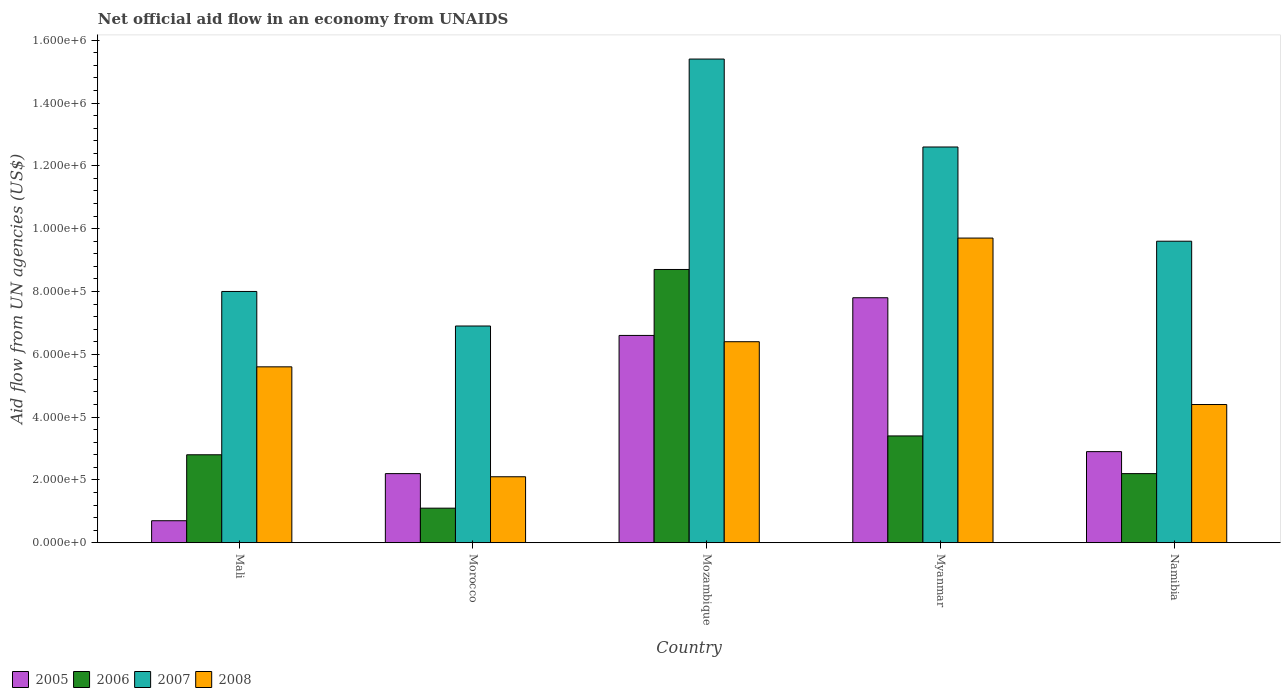How many groups of bars are there?
Provide a short and direct response. 5. Are the number of bars per tick equal to the number of legend labels?
Keep it short and to the point. Yes. What is the label of the 3rd group of bars from the left?
Offer a terse response. Mozambique. What is the net official aid flow in 2008 in Mali?
Provide a succinct answer. 5.60e+05. Across all countries, what is the maximum net official aid flow in 2006?
Offer a very short reply. 8.70e+05. In which country was the net official aid flow in 2008 maximum?
Your answer should be compact. Myanmar. In which country was the net official aid flow in 2005 minimum?
Your answer should be compact. Mali. What is the total net official aid flow in 2007 in the graph?
Give a very brief answer. 5.25e+06. What is the difference between the net official aid flow in 2007 in Mozambique and that in Myanmar?
Offer a terse response. 2.80e+05. What is the difference between the net official aid flow in 2006 in Mali and the net official aid flow in 2005 in Myanmar?
Provide a short and direct response. -5.00e+05. What is the average net official aid flow in 2005 per country?
Your answer should be very brief. 4.04e+05. In how many countries, is the net official aid flow in 2008 greater than 1080000 US$?
Your response must be concise. 0. What is the ratio of the net official aid flow in 2006 in Mali to that in Mozambique?
Keep it short and to the point. 0.32. Is the net official aid flow in 2008 in Mali less than that in Morocco?
Your answer should be very brief. No. Is the difference between the net official aid flow in 2007 in Mozambique and Namibia greater than the difference between the net official aid flow in 2005 in Mozambique and Namibia?
Offer a very short reply. Yes. What is the difference between the highest and the lowest net official aid flow in 2008?
Your answer should be compact. 7.60e+05. In how many countries, is the net official aid flow in 2006 greater than the average net official aid flow in 2006 taken over all countries?
Your answer should be very brief. 1. Is the sum of the net official aid flow in 2006 in Morocco and Namibia greater than the maximum net official aid flow in 2007 across all countries?
Your response must be concise. No. What does the 3rd bar from the left in Morocco represents?
Make the answer very short. 2007. What does the 4th bar from the right in Mozambique represents?
Provide a succinct answer. 2005. How many bars are there?
Your answer should be compact. 20. Are the values on the major ticks of Y-axis written in scientific E-notation?
Offer a terse response. Yes. Does the graph contain grids?
Your response must be concise. No. Where does the legend appear in the graph?
Provide a succinct answer. Bottom left. How many legend labels are there?
Provide a succinct answer. 4. What is the title of the graph?
Offer a terse response. Net official aid flow in an economy from UNAIDS. Does "1980" appear as one of the legend labels in the graph?
Ensure brevity in your answer.  No. What is the label or title of the X-axis?
Provide a succinct answer. Country. What is the label or title of the Y-axis?
Keep it short and to the point. Aid flow from UN agencies (US$). What is the Aid flow from UN agencies (US$) of 2006 in Mali?
Your response must be concise. 2.80e+05. What is the Aid flow from UN agencies (US$) of 2007 in Mali?
Provide a succinct answer. 8.00e+05. What is the Aid flow from UN agencies (US$) of 2008 in Mali?
Your response must be concise. 5.60e+05. What is the Aid flow from UN agencies (US$) in 2005 in Morocco?
Offer a terse response. 2.20e+05. What is the Aid flow from UN agencies (US$) of 2007 in Morocco?
Ensure brevity in your answer.  6.90e+05. What is the Aid flow from UN agencies (US$) in 2005 in Mozambique?
Ensure brevity in your answer.  6.60e+05. What is the Aid flow from UN agencies (US$) of 2006 in Mozambique?
Ensure brevity in your answer.  8.70e+05. What is the Aid flow from UN agencies (US$) in 2007 in Mozambique?
Give a very brief answer. 1.54e+06. What is the Aid flow from UN agencies (US$) in 2008 in Mozambique?
Offer a terse response. 6.40e+05. What is the Aid flow from UN agencies (US$) in 2005 in Myanmar?
Ensure brevity in your answer.  7.80e+05. What is the Aid flow from UN agencies (US$) in 2006 in Myanmar?
Make the answer very short. 3.40e+05. What is the Aid flow from UN agencies (US$) of 2007 in Myanmar?
Provide a succinct answer. 1.26e+06. What is the Aid flow from UN agencies (US$) in 2008 in Myanmar?
Your answer should be very brief. 9.70e+05. What is the Aid flow from UN agencies (US$) of 2006 in Namibia?
Provide a succinct answer. 2.20e+05. What is the Aid flow from UN agencies (US$) of 2007 in Namibia?
Ensure brevity in your answer.  9.60e+05. What is the Aid flow from UN agencies (US$) in 2008 in Namibia?
Offer a very short reply. 4.40e+05. Across all countries, what is the maximum Aid flow from UN agencies (US$) of 2005?
Your answer should be compact. 7.80e+05. Across all countries, what is the maximum Aid flow from UN agencies (US$) of 2006?
Your response must be concise. 8.70e+05. Across all countries, what is the maximum Aid flow from UN agencies (US$) of 2007?
Your answer should be very brief. 1.54e+06. Across all countries, what is the maximum Aid flow from UN agencies (US$) of 2008?
Offer a very short reply. 9.70e+05. Across all countries, what is the minimum Aid flow from UN agencies (US$) of 2007?
Provide a succinct answer. 6.90e+05. Across all countries, what is the minimum Aid flow from UN agencies (US$) in 2008?
Offer a terse response. 2.10e+05. What is the total Aid flow from UN agencies (US$) of 2005 in the graph?
Your answer should be compact. 2.02e+06. What is the total Aid flow from UN agencies (US$) in 2006 in the graph?
Provide a short and direct response. 1.82e+06. What is the total Aid flow from UN agencies (US$) in 2007 in the graph?
Your answer should be very brief. 5.25e+06. What is the total Aid flow from UN agencies (US$) of 2008 in the graph?
Provide a succinct answer. 2.82e+06. What is the difference between the Aid flow from UN agencies (US$) of 2007 in Mali and that in Morocco?
Offer a terse response. 1.10e+05. What is the difference between the Aid flow from UN agencies (US$) in 2005 in Mali and that in Mozambique?
Provide a succinct answer. -5.90e+05. What is the difference between the Aid flow from UN agencies (US$) of 2006 in Mali and that in Mozambique?
Provide a succinct answer. -5.90e+05. What is the difference between the Aid flow from UN agencies (US$) in 2007 in Mali and that in Mozambique?
Your answer should be very brief. -7.40e+05. What is the difference between the Aid flow from UN agencies (US$) of 2005 in Mali and that in Myanmar?
Offer a very short reply. -7.10e+05. What is the difference between the Aid flow from UN agencies (US$) of 2006 in Mali and that in Myanmar?
Provide a succinct answer. -6.00e+04. What is the difference between the Aid flow from UN agencies (US$) in 2007 in Mali and that in Myanmar?
Your answer should be very brief. -4.60e+05. What is the difference between the Aid flow from UN agencies (US$) in 2008 in Mali and that in Myanmar?
Ensure brevity in your answer.  -4.10e+05. What is the difference between the Aid flow from UN agencies (US$) of 2006 in Mali and that in Namibia?
Your answer should be very brief. 6.00e+04. What is the difference between the Aid flow from UN agencies (US$) in 2008 in Mali and that in Namibia?
Your answer should be very brief. 1.20e+05. What is the difference between the Aid flow from UN agencies (US$) of 2005 in Morocco and that in Mozambique?
Ensure brevity in your answer.  -4.40e+05. What is the difference between the Aid flow from UN agencies (US$) of 2006 in Morocco and that in Mozambique?
Your answer should be very brief. -7.60e+05. What is the difference between the Aid flow from UN agencies (US$) in 2007 in Morocco and that in Mozambique?
Provide a short and direct response. -8.50e+05. What is the difference between the Aid flow from UN agencies (US$) in 2008 in Morocco and that in Mozambique?
Offer a terse response. -4.30e+05. What is the difference between the Aid flow from UN agencies (US$) in 2005 in Morocco and that in Myanmar?
Give a very brief answer. -5.60e+05. What is the difference between the Aid flow from UN agencies (US$) in 2006 in Morocco and that in Myanmar?
Ensure brevity in your answer.  -2.30e+05. What is the difference between the Aid flow from UN agencies (US$) of 2007 in Morocco and that in Myanmar?
Provide a short and direct response. -5.70e+05. What is the difference between the Aid flow from UN agencies (US$) of 2008 in Morocco and that in Myanmar?
Give a very brief answer. -7.60e+05. What is the difference between the Aid flow from UN agencies (US$) in 2008 in Morocco and that in Namibia?
Offer a very short reply. -2.30e+05. What is the difference between the Aid flow from UN agencies (US$) of 2006 in Mozambique and that in Myanmar?
Your answer should be very brief. 5.30e+05. What is the difference between the Aid flow from UN agencies (US$) of 2008 in Mozambique and that in Myanmar?
Make the answer very short. -3.30e+05. What is the difference between the Aid flow from UN agencies (US$) in 2005 in Mozambique and that in Namibia?
Ensure brevity in your answer.  3.70e+05. What is the difference between the Aid flow from UN agencies (US$) of 2006 in Mozambique and that in Namibia?
Your answer should be compact. 6.50e+05. What is the difference between the Aid flow from UN agencies (US$) of 2007 in Mozambique and that in Namibia?
Give a very brief answer. 5.80e+05. What is the difference between the Aid flow from UN agencies (US$) in 2005 in Myanmar and that in Namibia?
Offer a very short reply. 4.90e+05. What is the difference between the Aid flow from UN agencies (US$) in 2006 in Myanmar and that in Namibia?
Provide a short and direct response. 1.20e+05. What is the difference between the Aid flow from UN agencies (US$) in 2007 in Myanmar and that in Namibia?
Give a very brief answer. 3.00e+05. What is the difference between the Aid flow from UN agencies (US$) in 2008 in Myanmar and that in Namibia?
Offer a terse response. 5.30e+05. What is the difference between the Aid flow from UN agencies (US$) in 2005 in Mali and the Aid flow from UN agencies (US$) in 2007 in Morocco?
Provide a short and direct response. -6.20e+05. What is the difference between the Aid flow from UN agencies (US$) in 2006 in Mali and the Aid flow from UN agencies (US$) in 2007 in Morocco?
Provide a succinct answer. -4.10e+05. What is the difference between the Aid flow from UN agencies (US$) in 2006 in Mali and the Aid flow from UN agencies (US$) in 2008 in Morocco?
Provide a succinct answer. 7.00e+04. What is the difference between the Aid flow from UN agencies (US$) in 2007 in Mali and the Aid flow from UN agencies (US$) in 2008 in Morocco?
Make the answer very short. 5.90e+05. What is the difference between the Aid flow from UN agencies (US$) of 2005 in Mali and the Aid flow from UN agencies (US$) of 2006 in Mozambique?
Provide a short and direct response. -8.00e+05. What is the difference between the Aid flow from UN agencies (US$) of 2005 in Mali and the Aid flow from UN agencies (US$) of 2007 in Mozambique?
Your response must be concise. -1.47e+06. What is the difference between the Aid flow from UN agencies (US$) in 2005 in Mali and the Aid flow from UN agencies (US$) in 2008 in Mozambique?
Provide a succinct answer. -5.70e+05. What is the difference between the Aid flow from UN agencies (US$) in 2006 in Mali and the Aid flow from UN agencies (US$) in 2007 in Mozambique?
Provide a short and direct response. -1.26e+06. What is the difference between the Aid flow from UN agencies (US$) of 2006 in Mali and the Aid flow from UN agencies (US$) of 2008 in Mozambique?
Your answer should be very brief. -3.60e+05. What is the difference between the Aid flow from UN agencies (US$) of 2007 in Mali and the Aid flow from UN agencies (US$) of 2008 in Mozambique?
Keep it short and to the point. 1.60e+05. What is the difference between the Aid flow from UN agencies (US$) of 2005 in Mali and the Aid flow from UN agencies (US$) of 2007 in Myanmar?
Give a very brief answer. -1.19e+06. What is the difference between the Aid flow from UN agencies (US$) in 2005 in Mali and the Aid flow from UN agencies (US$) in 2008 in Myanmar?
Make the answer very short. -9.00e+05. What is the difference between the Aid flow from UN agencies (US$) in 2006 in Mali and the Aid flow from UN agencies (US$) in 2007 in Myanmar?
Offer a terse response. -9.80e+05. What is the difference between the Aid flow from UN agencies (US$) in 2006 in Mali and the Aid flow from UN agencies (US$) in 2008 in Myanmar?
Provide a succinct answer. -6.90e+05. What is the difference between the Aid flow from UN agencies (US$) in 2007 in Mali and the Aid flow from UN agencies (US$) in 2008 in Myanmar?
Provide a short and direct response. -1.70e+05. What is the difference between the Aid flow from UN agencies (US$) in 2005 in Mali and the Aid flow from UN agencies (US$) in 2006 in Namibia?
Keep it short and to the point. -1.50e+05. What is the difference between the Aid flow from UN agencies (US$) of 2005 in Mali and the Aid flow from UN agencies (US$) of 2007 in Namibia?
Your response must be concise. -8.90e+05. What is the difference between the Aid flow from UN agencies (US$) of 2005 in Mali and the Aid flow from UN agencies (US$) of 2008 in Namibia?
Offer a very short reply. -3.70e+05. What is the difference between the Aid flow from UN agencies (US$) of 2006 in Mali and the Aid flow from UN agencies (US$) of 2007 in Namibia?
Provide a succinct answer. -6.80e+05. What is the difference between the Aid flow from UN agencies (US$) of 2006 in Mali and the Aid flow from UN agencies (US$) of 2008 in Namibia?
Give a very brief answer. -1.60e+05. What is the difference between the Aid flow from UN agencies (US$) of 2005 in Morocco and the Aid flow from UN agencies (US$) of 2006 in Mozambique?
Provide a short and direct response. -6.50e+05. What is the difference between the Aid flow from UN agencies (US$) of 2005 in Morocco and the Aid flow from UN agencies (US$) of 2007 in Mozambique?
Offer a very short reply. -1.32e+06. What is the difference between the Aid flow from UN agencies (US$) of 2005 in Morocco and the Aid flow from UN agencies (US$) of 2008 in Mozambique?
Give a very brief answer. -4.20e+05. What is the difference between the Aid flow from UN agencies (US$) in 2006 in Morocco and the Aid flow from UN agencies (US$) in 2007 in Mozambique?
Your response must be concise. -1.43e+06. What is the difference between the Aid flow from UN agencies (US$) of 2006 in Morocco and the Aid flow from UN agencies (US$) of 2008 in Mozambique?
Offer a terse response. -5.30e+05. What is the difference between the Aid flow from UN agencies (US$) in 2005 in Morocco and the Aid flow from UN agencies (US$) in 2007 in Myanmar?
Keep it short and to the point. -1.04e+06. What is the difference between the Aid flow from UN agencies (US$) in 2005 in Morocco and the Aid flow from UN agencies (US$) in 2008 in Myanmar?
Your answer should be compact. -7.50e+05. What is the difference between the Aid flow from UN agencies (US$) in 2006 in Morocco and the Aid flow from UN agencies (US$) in 2007 in Myanmar?
Make the answer very short. -1.15e+06. What is the difference between the Aid flow from UN agencies (US$) in 2006 in Morocco and the Aid flow from UN agencies (US$) in 2008 in Myanmar?
Provide a short and direct response. -8.60e+05. What is the difference between the Aid flow from UN agencies (US$) of 2007 in Morocco and the Aid flow from UN agencies (US$) of 2008 in Myanmar?
Provide a short and direct response. -2.80e+05. What is the difference between the Aid flow from UN agencies (US$) in 2005 in Morocco and the Aid flow from UN agencies (US$) in 2007 in Namibia?
Keep it short and to the point. -7.40e+05. What is the difference between the Aid flow from UN agencies (US$) of 2006 in Morocco and the Aid flow from UN agencies (US$) of 2007 in Namibia?
Give a very brief answer. -8.50e+05. What is the difference between the Aid flow from UN agencies (US$) in 2006 in Morocco and the Aid flow from UN agencies (US$) in 2008 in Namibia?
Provide a short and direct response. -3.30e+05. What is the difference between the Aid flow from UN agencies (US$) in 2005 in Mozambique and the Aid flow from UN agencies (US$) in 2006 in Myanmar?
Your answer should be very brief. 3.20e+05. What is the difference between the Aid flow from UN agencies (US$) in 2005 in Mozambique and the Aid flow from UN agencies (US$) in 2007 in Myanmar?
Keep it short and to the point. -6.00e+05. What is the difference between the Aid flow from UN agencies (US$) in 2005 in Mozambique and the Aid flow from UN agencies (US$) in 2008 in Myanmar?
Ensure brevity in your answer.  -3.10e+05. What is the difference between the Aid flow from UN agencies (US$) in 2006 in Mozambique and the Aid flow from UN agencies (US$) in 2007 in Myanmar?
Provide a succinct answer. -3.90e+05. What is the difference between the Aid flow from UN agencies (US$) in 2006 in Mozambique and the Aid flow from UN agencies (US$) in 2008 in Myanmar?
Your answer should be very brief. -1.00e+05. What is the difference between the Aid flow from UN agencies (US$) of 2007 in Mozambique and the Aid flow from UN agencies (US$) of 2008 in Myanmar?
Ensure brevity in your answer.  5.70e+05. What is the difference between the Aid flow from UN agencies (US$) in 2005 in Mozambique and the Aid flow from UN agencies (US$) in 2006 in Namibia?
Your answer should be compact. 4.40e+05. What is the difference between the Aid flow from UN agencies (US$) of 2006 in Mozambique and the Aid flow from UN agencies (US$) of 2007 in Namibia?
Make the answer very short. -9.00e+04. What is the difference between the Aid flow from UN agencies (US$) of 2006 in Mozambique and the Aid flow from UN agencies (US$) of 2008 in Namibia?
Your response must be concise. 4.30e+05. What is the difference between the Aid flow from UN agencies (US$) of 2007 in Mozambique and the Aid flow from UN agencies (US$) of 2008 in Namibia?
Your answer should be compact. 1.10e+06. What is the difference between the Aid flow from UN agencies (US$) in 2005 in Myanmar and the Aid flow from UN agencies (US$) in 2006 in Namibia?
Your answer should be compact. 5.60e+05. What is the difference between the Aid flow from UN agencies (US$) in 2006 in Myanmar and the Aid flow from UN agencies (US$) in 2007 in Namibia?
Keep it short and to the point. -6.20e+05. What is the difference between the Aid flow from UN agencies (US$) of 2007 in Myanmar and the Aid flow from UN agencies (US$) of 2008 in Namibia?
Ensure brevity in your answer.  8.20e+05. What is the average Aid flow from UN agencies (US$) in 2005 per country?
Make the answer very short. 4.04e+05. What is the average Aid flow from UN agencies (US$) in 2006 per country?
Your response must be concise. 3.64e+05. What is the average Aid flow from UN agencies (US$) of 2007 per country?
Offer a very short reply. 1.05e+06. What is the average Aid flow from UN agencies (US$) in 2008 per country?
Your answer should be very brief. 5.64e+05. What is the difference between the Aid flow from UN agencies (US$) in 2005 and Aid flow from UN agencies (US$) in 2006 in Mali?
Provide a succinct answer. -2.10e+05. What is the difference between the Aid flow from UN agencies (US$) of 2005 and Aid flow from UN agencies (US$) of 2007 in Mali?
Provide a short and direct response. -7.30e+05. What is the difference between the Aid flow from UN agencies (US$) in 2005 and Aid flow from UN agencies (US$) in 2008 in Mali?
Provide a succinct answer. -4.90e+05. What is the difference between the Aid flow from UN agencies (US$) of 2006 and Aid flow from UN agencies (US$) of 2007 in Mali?
Offer a very short reply. -5.20e+05. What is the difference between the Aid flow from UN agencies (US$) in 2006 and Aid flow from UN agencies (US$) in 2008 in Mali?
Ensure brevity in your answer.  -2.80e+05. What is the difference between the Aid flow from UN agencies (US$) of 2005 and Aid flow from UN agencies (US$) of 2007 in Morocco?
Offer a terse response. -4.70e+05. What is the difference between the Aid flow from UN agencies (US$) in 2006 and Aid flow from UN agencies (US$) in 2007 in Morocco?
Ensure brevity in your answer.  -5.80e+05. What is the difference between the Aid flow from UN agencies (US$) of 2007 and Aid flow from UN agencies (US$) of 2008 in Morocco?
Offer a very short reply. 4.80e+05. What is the difference between the Aid flow from UN agencies (US$) in 2005 and Aid flow from UN agencies (US$) in 2006 in Mozambique?
Make the answer very short. -2.10e+05. What is the difference between the Aid flow from UN agencies (US$) of 2005 and Aid flow from UN agencies (US$) of 2007 in Mozambique?
Keep it short and to the point. -8.80e+05. What is the difference between the Aid flow from UN agencies (US$) of 2005 and Aid flow from UN agencies (US$) of 2008 in Mozambique?
Keep it short and to the point. 2.00e+04. What is the difference between the Aid flow from UN agencies (US$) of 2006 and Aid flow from UN agencies (US$) of 2007 in Mozambique?
Offer a terse response. -6.70e+05. What is the difference between the Aid flow from UN agencies (US$) in 2006 and Aid flow from UN agencies (US$) in 2008 in Mozambique?
Keep it short and to the point. 2.30e+05. What is the difference between the Aid flow from UN agencies (US$) of 2005 and Aid flow from UN agencies (US$) of 2006 in Myanmar?
Your answer should be compact. 4.40e+05. What is the difference between the Aid flow from UN agencies (US$) of 2005 and Aid flow from UN agencies (US$) of 2007 in Myanmar?
Your answer should be very brief. -4.80e+05. What is the difference between the Aid flow from UN agencies (US$) of 2005 and Aid flow from UN agencies (US$) of 2008 in Myanmar?
Your response must be concise. -1.90e+05. What is the difference between the Aid flow from UN agencies (US$) of 2006 and Aid flow from UN agencies (US$) of 2007 in Myanmar?
Your answer should be very brief. -9.20e+05. What is the difference between the Aid flow from UN agencies (US$) of 2006 and Aid flow from UN agencies (US$) of 2008 in Myanmar?
Your response must be concise. -6.30e+05. What is the difference between the Aid flow from UN agencies (US$) in 2007 and Aid flow from UN agencies (US$) in 2008 in Myanmar?
Ensure brevity in your answer.  2.90e+05. What is the difference between the Aid flow from UN agencies (US$) in 2005 and Aid flow from UN agencies (US$) in 2006 in Namibia?
Your answer should be compact. 7.00e+04. What is the difference between the Aid flow from UN agencies (US$) in 2005 and Aid flow from UN agencies (US$) in 2007 in Namibia?
Your response must be concise. -6.70e+05. What is the difference between the Aid flow from UN agencies (US$) in 2006 and Aid flow from UN agencies (US$) in 2007 in Namibia?
Offer a terse response. -7.40e+05. What is the difference between the Aid flow from UN agencies (US$) in 2006 and Aid flow from UN agencies (US$) in 2008 in Namibia?
Provide a succinct answer. -2.20e+05. What is the difference between the Aid flow from UN agencies (US$) of 2007 and Aid flow from UN agencies (US$) of 2008 in Namibia?
Make the answer very short. 5.20e+05. What is the ratio of the Aid flow from UN agencies (US$) in 2005 in Mali to that in Morocco?
Ensure brevity in your answer.  0.32. What is the ratio of the Aid flow from UN agencies (US$) of 2006 in Mali to that in Morocco?
Give a very brief answer. 2.55. What is the ratio of the Aid flow from UN agencies (US$) of 2007 in Mali to that in Morocco?
Ensure brevity in your answer.  1.16. What is the ratio of the Aid flow from UN agencies (US$) of 2008 in Mali to that in Morocco?
Provide a succinct answer. 2.67. What is the ratio of the Aid flow from UN agencies (US$) of 2005 in Mali to that in Mozambique?
Ensure brevity in your answer.  0.11. What is the ratio of the Aid flow from UN agencies (US$) in 2006 in Mali to that in Mozambique?
Provide a short and direct response. 0.32. What is the ratio of the Aid flow from UN agencies (US$) of 2007 in Mali to that in Mozambique?
Your answer should be compact. 0.52. What is the ratio of the Aid flow from UN agencies (US$) of 2005 in Mali to that in Myanmar?
Give a very brief answer. 0.09. What is the ratio of the Aid flow from UN agencies (US$) of 2006 in Mali to that in Myanmar?
Your answer should be compact. 0.82. What is the ratio of the Aid flow from UN agencies (US$) in 2007 in Mali to that in Myanmar?
Your answer should be very brief. 0.63. What is the ratio of the Aid flow from UN agencies (US$) of 2008 in Mali to that in Myanmar?
Make the answer very short. 0.58. What is the ratio of the Aid flow from UN agencies (US$) in 2005 in Mali to that in Namibia?
Offer a very short reply. 0.24. What is the ratio of the Aid flow from UN agencies (US$) of 2006 in Mali to that in Namibia?
Your response must be concise. 1.27. What is the ratio of the Aid flow from UN agencies (US$) of 2008 in Mali to that in Namibia?
Ensure brevity in your answer.  1.27. What is the ratio of the Aid flow from UN agencies (US$) of 2005 in Morocco to that in Mozambique?
Offer a very short reply. 0.33. What is the ratio of the Aid flow from UN agencies (US$) in 2006 in Morocco to that in Mozambique?
Provide a short and direct response. 0.13. What is the ratio of the Aid flow from UN agencies (US$) in 2007 in Morocco to that in Mozambique?
Your answer should be very brief. 0.45. What is the ratio of the Aid flow from UN agencies (US$) of 2008 in Morocco to that in Mozambique?
Provide a short and direct response. 0.33. What is the ratio of the Aid flow from UN agencies (US$) of 2005 in Morocco to that in Myanmar?
Your answer should be very brief. 0.28. What is the ratio of the Aid flow from UN agencies (US$) of 2006 in Morocco to that in Myanmar?
Make the answer very short. 0.32. What is the ratio of the Aid flow from UN agencies (US$) of 2007 in Morocco to that in Myanmar?
Give a very brief answer. 0.55. What is the ratio of the Aid flow from UN agencies (US$) of 2008 in Morocco to that in Myanmar?
Keep it short and to the point. 0.22. What is the ratio of the Aid flow from UN agencies (US$) in 2005 in Morocco to that in Namibia?
Ensure brevity in your answer.  0.76. What is the ratio of the Aid flow from UN agencies (US$) in 2006 in Morocco to that in Namibia?
Your response must be concise. 0.5. What is the ratio of the Aid flow from UN agencies (US$) in 2007 in Morocco to that in Namibia?
Your answer should be compact. 0.72. What is the ratio of the Aid flow from UN agencies (US$) of 2008 in Morocco to that in Namibia?
Your answer should be very brief. 0.48. What is the ratio of the Aid flow from UN agencies (US$) in 2005 in Mozambique to that in Myanmar?
Offer a very short reply. 0.85. What is the ratio of the Aid flow from UN agencies (US$) in 2006 in Mozambique to that in Myanmar?
Provide a succinct answer. 2.56. What is the ratio of the Aid flow from UN agencies (US$) in 2007 in Mozambique to that in Myanmar?
Your answer should be compact. 1.22. What is the ratio of the Aid flow from UN agencies (US$) of 2008 in Mozambique to that in Myanmar?
Offer a very short reply. 0.66. What is the ratio of the Aid flow from UN agencies (US$) in 2005 in Mozambique to that in Namibia?
Offer a very short reply. 2.28. What is the ratio of the Aid flow from UN agencies (US$) in 2006 in Mozambique to that in Namibia?
Provide a succinct answer. 3.95. What is the ratio of the Aid flow from UN agencies (US$) in 2007 in Mozambique to that in Namibia?
Offer a very short reply. 1.6. What is the ratio of the Aid flow from UN agencies (US$) of 2008 in Mozambique to that in Namibia?
Provide a succinct answer. 1.45. What is the ratio of the Aid flow from UN agencies (US$) of 2005 in Myanmar to that in Namibia?
Your answer should be compact. 2.69. What is the ratio of the Aid flow from UN agencies (US$) in 2006 in Myanmar to that in Namibia?
Provide a short and direct response. 1.55. What is the ratio of the Aid flow from UN agencies (US$) in 2007 in Myanmar to that in Namibia?
Give a very brief answer. 1.31. What is the ratio of the Aid flow from UN agencies (US$) in 2008 in Myanmar to that in Namibia?
Your response must be concise. 2.2. What is the difference between the highest and the second highest Aid flow from UN agencies (US$) of 2006?
Your answer should be compact. 5.30e+05. What is the difference between the highest and the second highest Aid flow from UN agencies (US$) in 2008?
Your answer should be very brief. 3.30e+05. What is the difference between the highest and the lowest Aid flow from UN agencies (US$) in 2005?
Your response must be concise. 7.10e+05. What is the difference between the highest and the lowest Aid flow from UN agencies (US$) of 2006?
Your response must be concise. 7.60e+05. What is the difference between the highest and the lowest Aid flow from UN agencies (US$) in 2007?
Offer a terse response. 8.50e+05. What is the difference between the highest and the lowest Aid flow from UN agencies (US$) of 2008?
Your answer should be compact. 7.60e+05. 